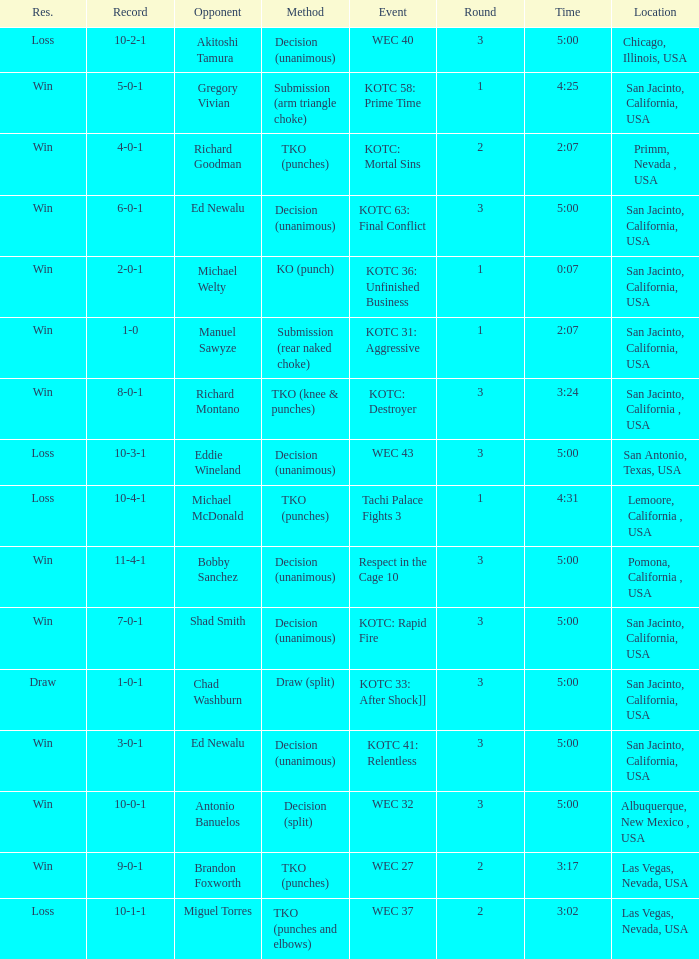What time did the even tachi palace fights 3 take place? 4:31. 